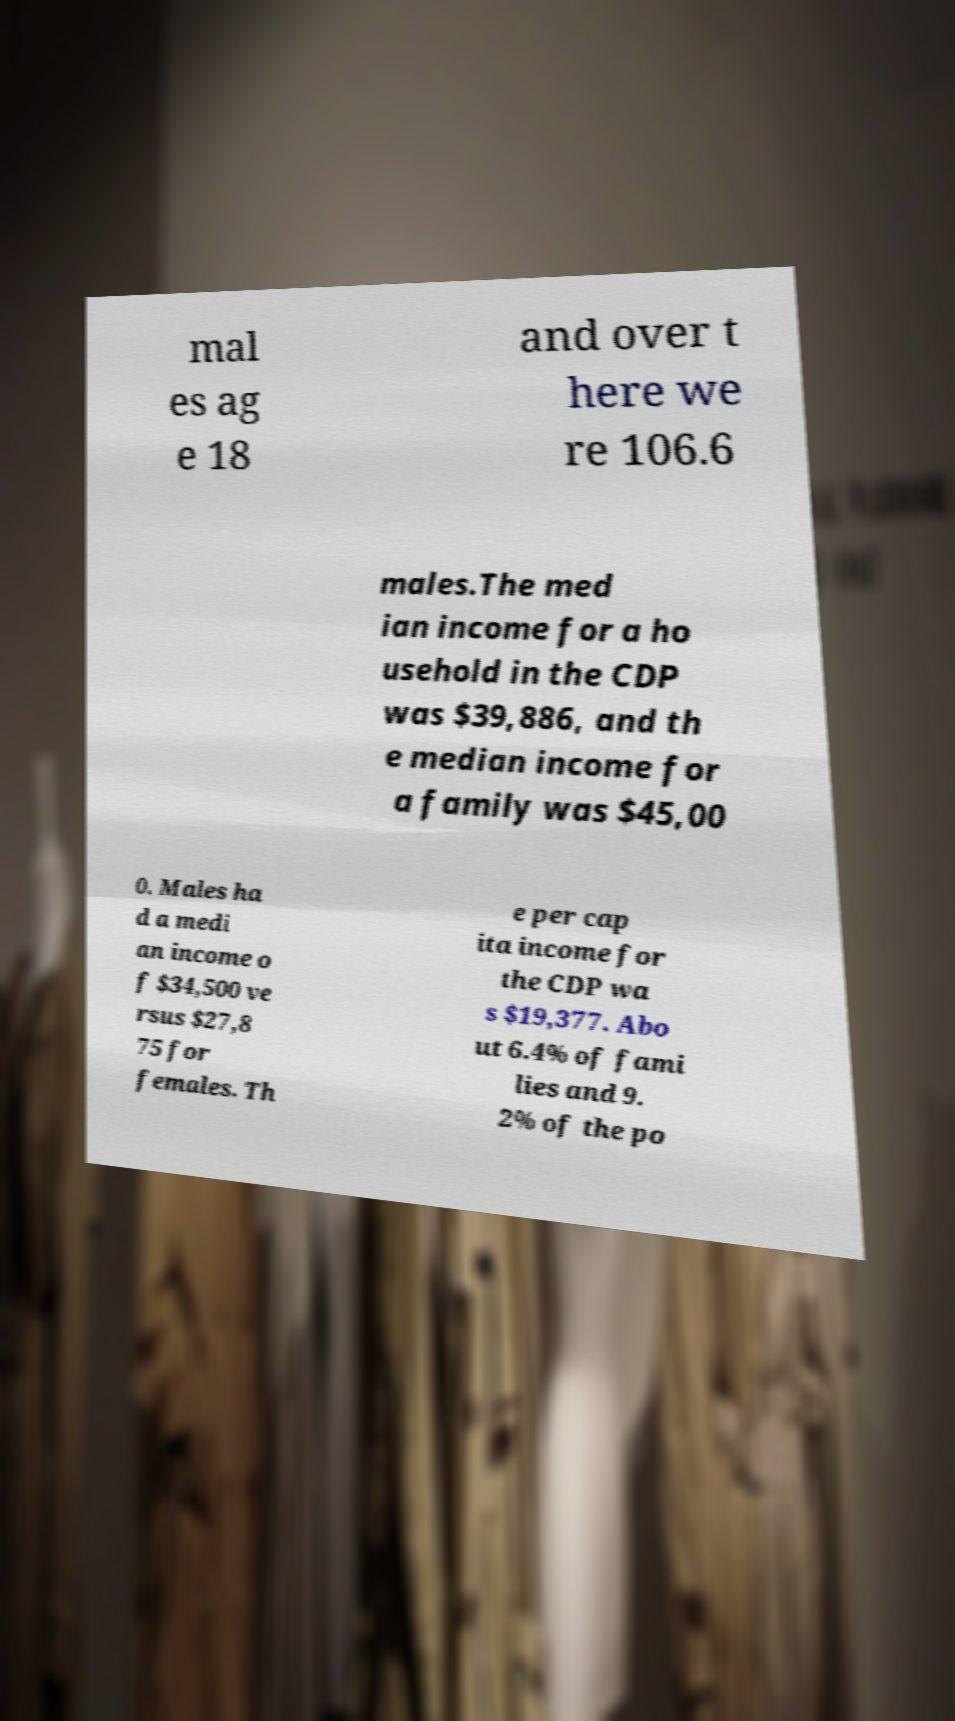Can you read and provide the text displayed in the image?This photo seems to have some interesting text. Can you extract and type it out for me? mal es ag e 18 and over t here we re 106.6 males.The med ian income for a ho usehold in the CDP was $39,886, and th e median income for a family was $45,00 0. Males ha d a medi an income o f $34,500 ve rsus $27,8 75 for females. Th e per cap ita income for the CDP wa s $19,377. Abo ut 6.4% of fami lies and 9. 2% of the po 